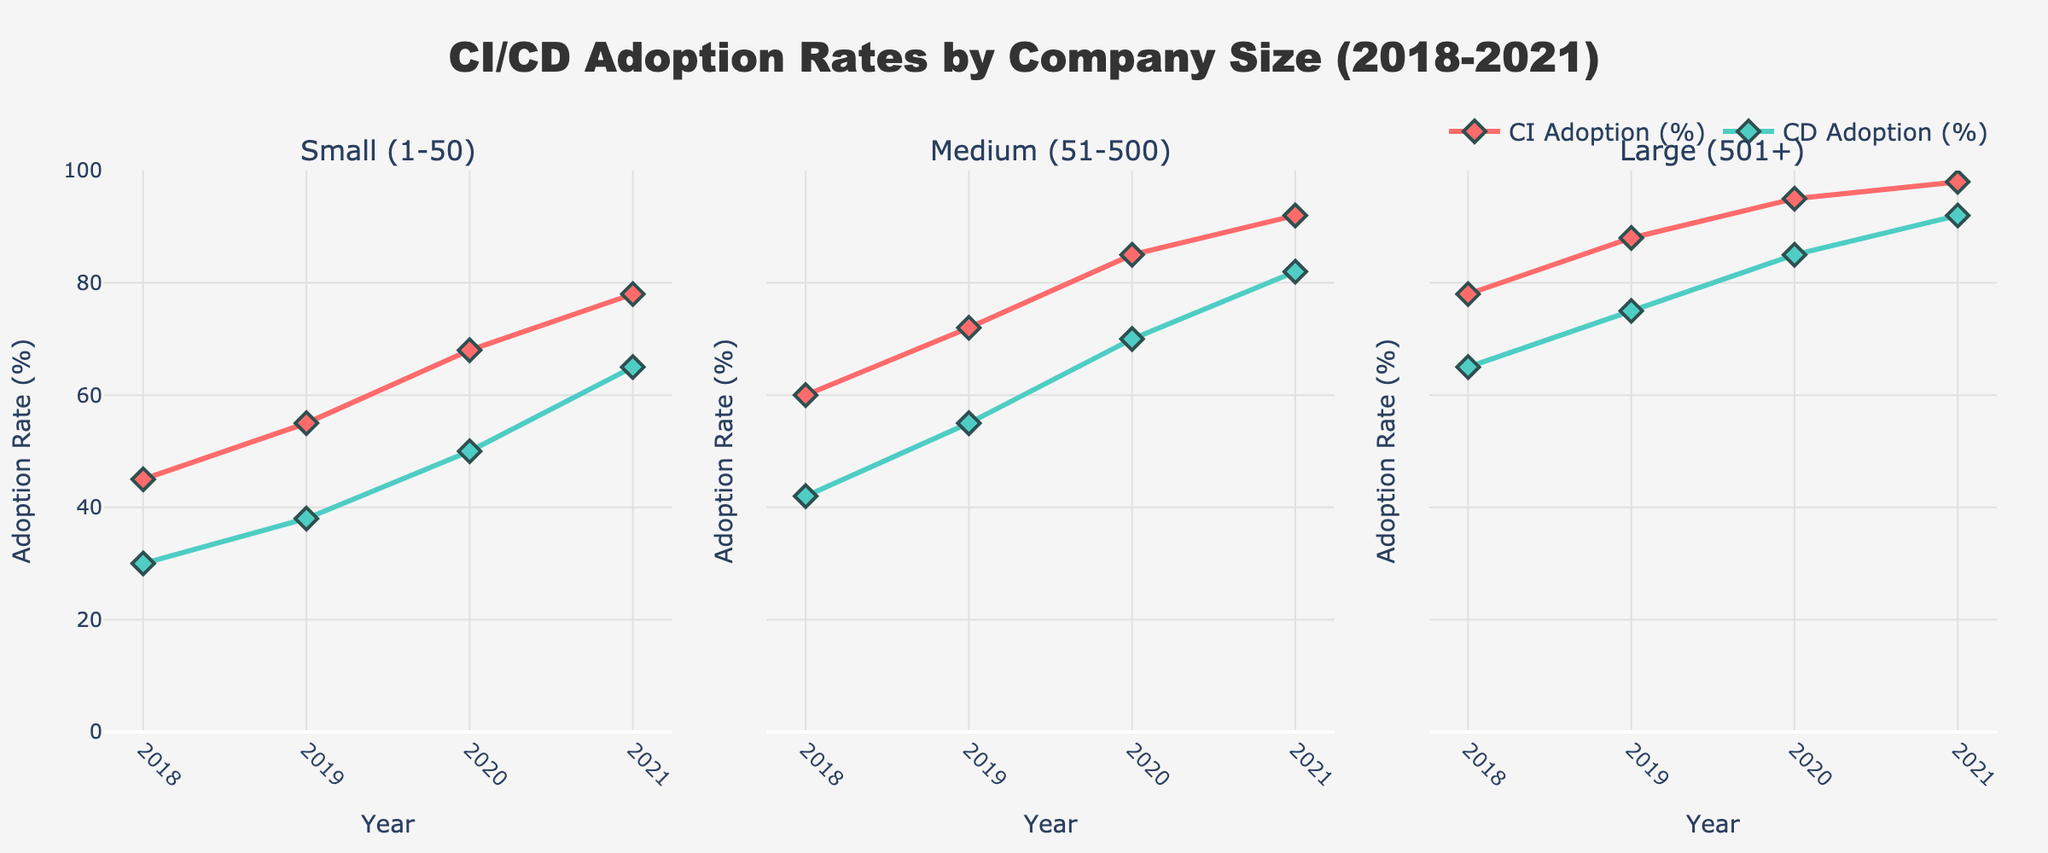How many company sizes are represented in the figure? The figure comprises subplots for each company size to depict adoption rates. Counting the subplot titles will reveal the number of represented company sizes.
Answer: 3 What is the title of the plot? The title is displayed at the top of the figure and provides a summary of the main theme represented in the plots.
Answer: CI/CD Adoption Rates by Company Size (2018-2021) How does the CI adoption rate for small companies change from 2018 to 2021? Look at the subplot for small companies and observe the CI adoption line from 2018 to 2021. Note the value changes at each year.
Answer: It increases from 45% to 78% Which company size had the highest CD adoption rate in 2021? Examine the CD adoption rates for each company size in 2021 within the respective subplots. Identify the highest value.
Answer: Large (501+) What is the difference between the CI adoption rates of medium and large companies in 2019? Find the CI adoption rates for medium and large companies in the 2019 subplot, then subtract the value for medium companies from the value for large companies.
Answer: 16% Which company size shows the most significant increase in CI adoption rates from 2018 to 2021? Compare the CI adoption rate differences from 2018 to 2021 among the three subplots. Identify the largest increase.
Answer: Medium (51-500) What is the average CD adoption rate for small companies over the years 2018-2021? Add up the CD adoption rates for small companies from 2018, 2019, 2020, and 2021, then divide the sum by 4 to find the average.
Answer: 45.75% Did any company size reach or exceed a 90% CI adoption rate before 2021? Examine the CI adoption rate lines for all company sizes up to the year 2020. Check if any value is 90% or higher.
Answer: Yes Compare the CI and CD adoption rates for medium-sized companies in 2020. Which one is higher? Look at medium-sized companies' subplot for 2020 and compare the CI and CD adoption rates. Indicate the higher value.
Answer: CI adoption rate What trend can you observe in CI/CD adoption rates across all company sizes from 2018 to 2021? By examining all subplots, observe if CI and CD adoption rates are increasing, decreasing, or remaining constant over the years.
Answer: Increasing 